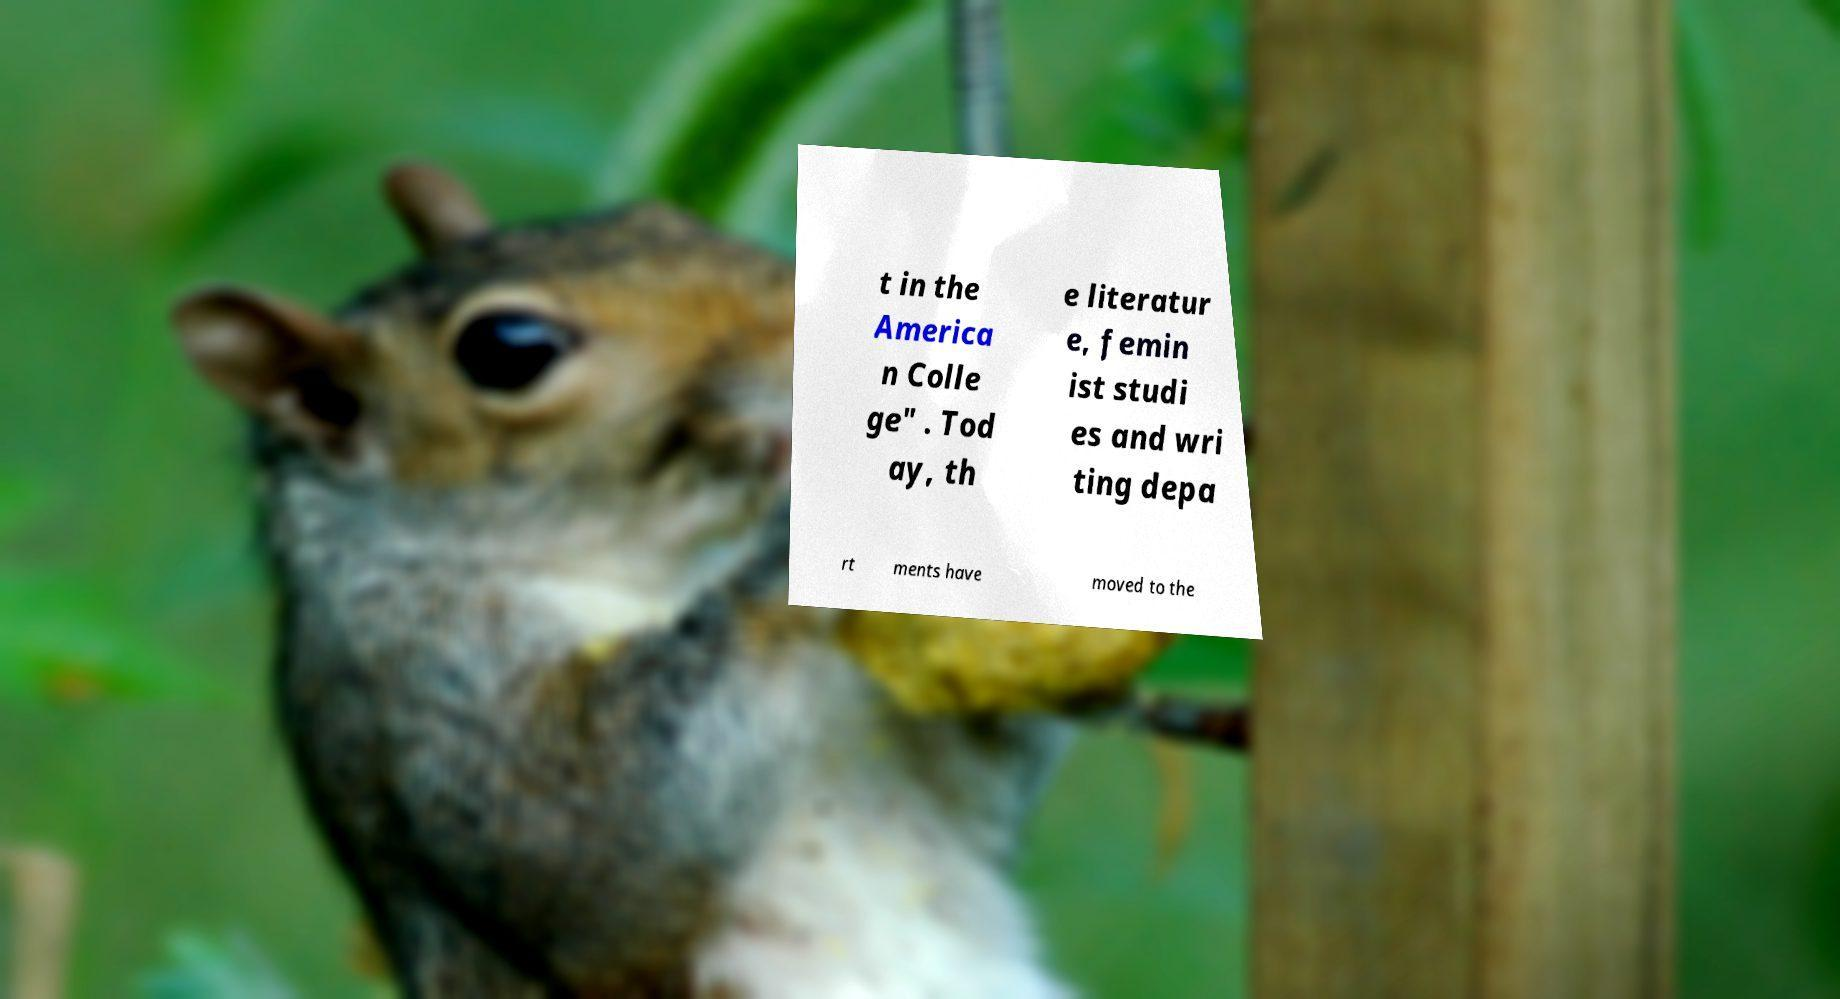I need the written content from this picture converted into text. Can you do that? t in the America n Colle ge" . Tod ay, th e literatur e, femin ist studi es and wri ting depa rt ments have moved to the 